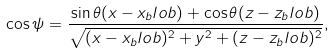Convert formula to latex. <formula><loc_0><loc_0><loc_500><loc_500>\cos \psi = \frac { \sin { \theta } ( x - x _ { b } l o b ) + \cos { \theta } ( z - z _ { b } l o b ) } { \sqrt { ( x - x _ { b } l o b ) ^ { 2 } + y ^ { 2 } + ( z - z _ { b } l o b ) ^ { 2 } } } ,</formula> 